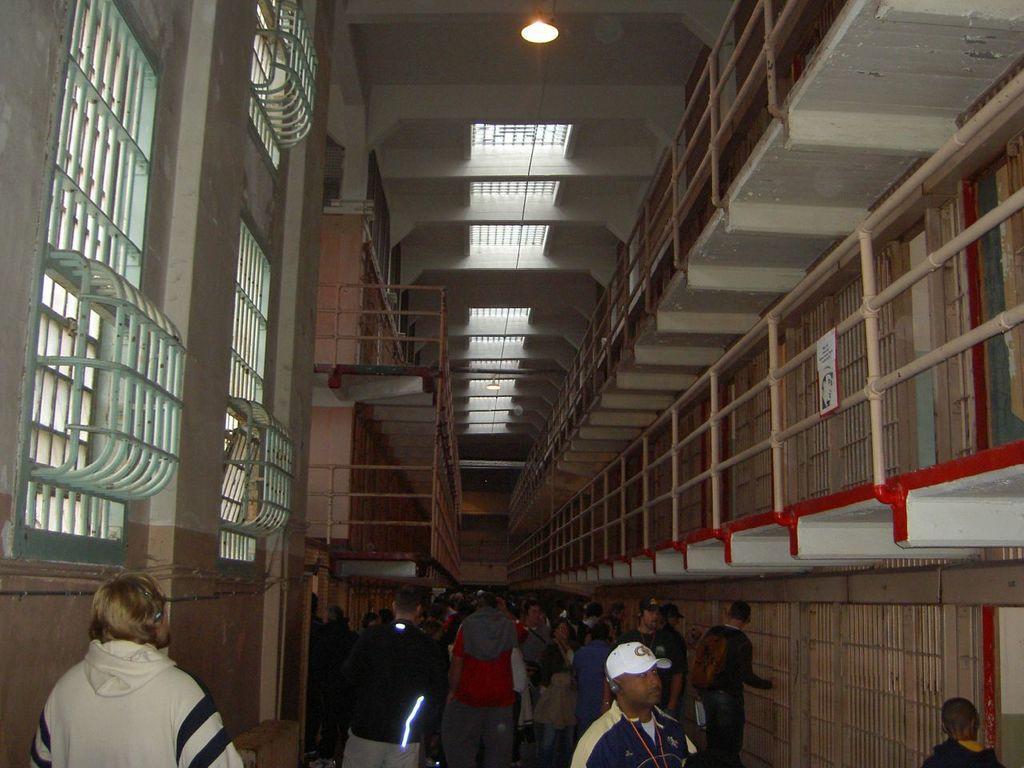In one or two sentences, can you explain what this image depicts? In this picture we can see a few people. We can see some text and a person on a white surface. There are a few rods and a light is visible on top of the picture. 